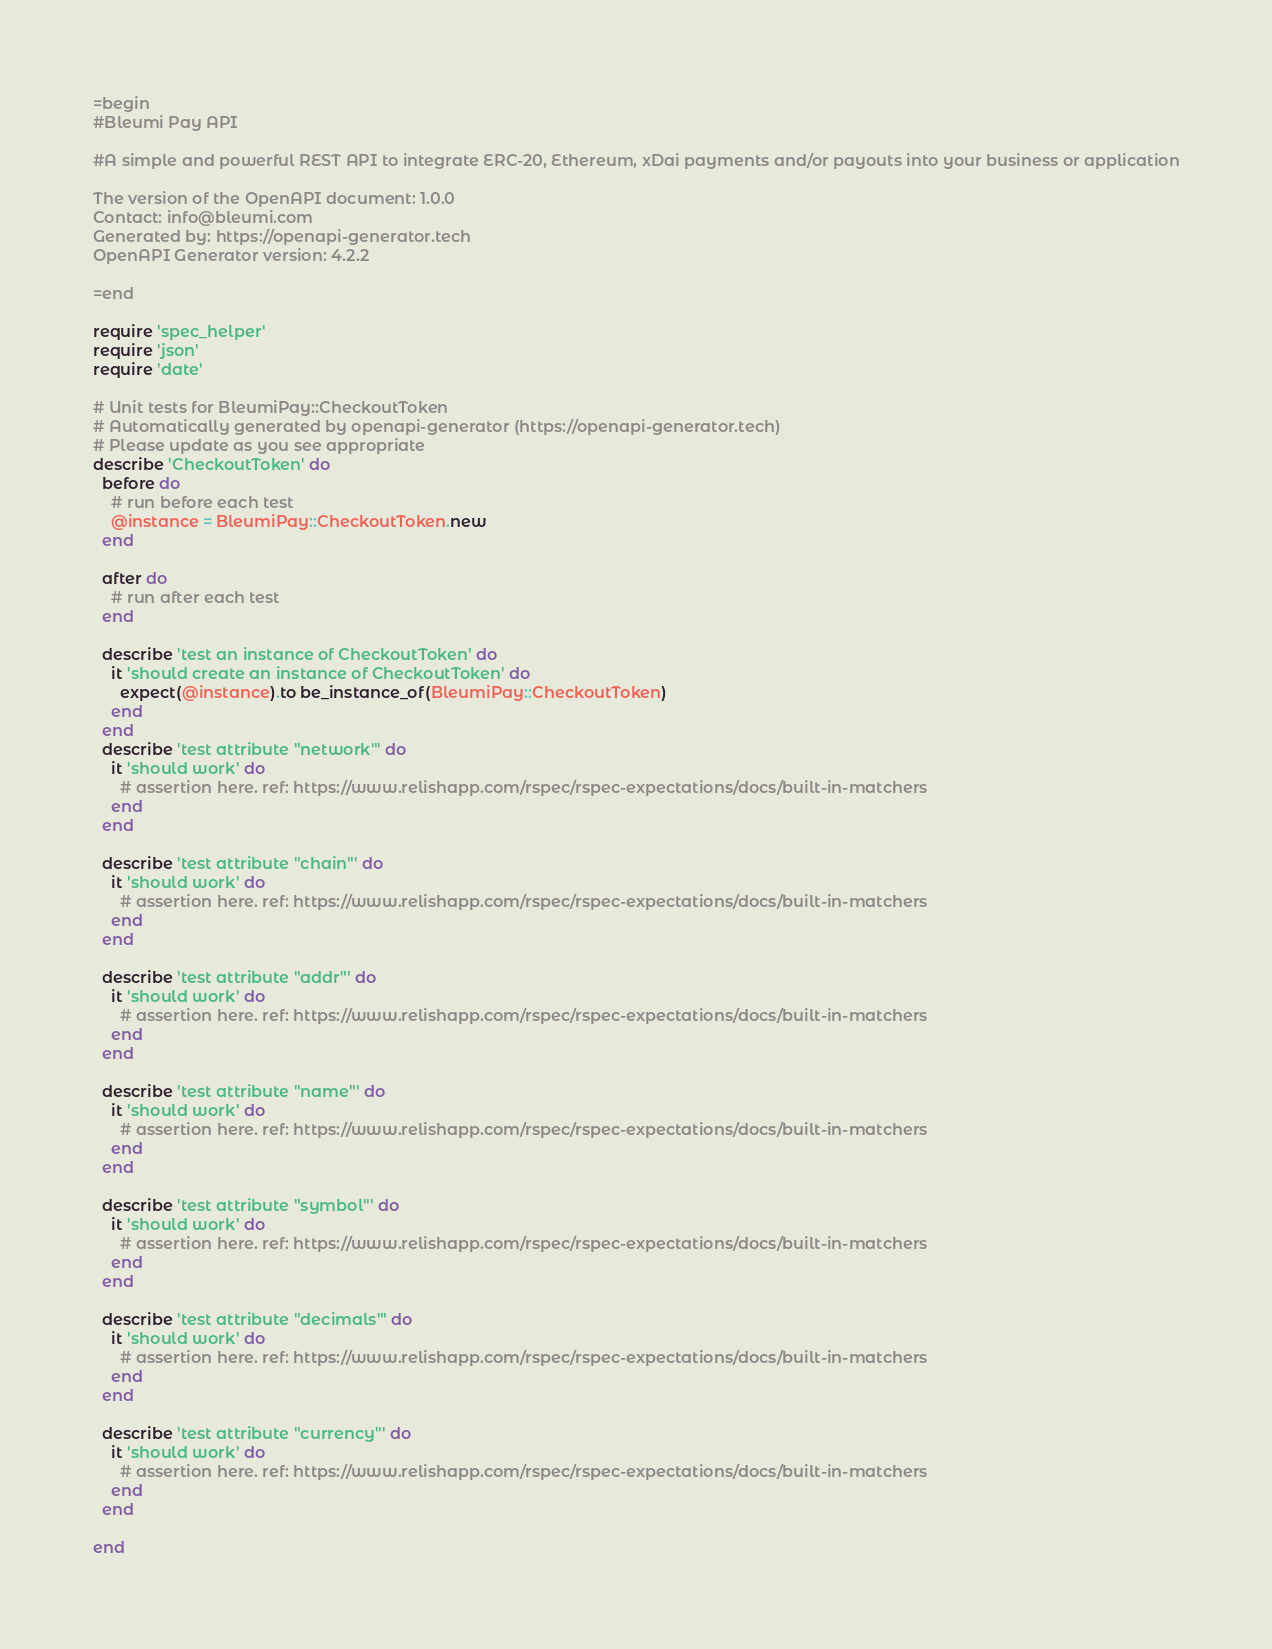Convert code to text. <code><loc_0><loc_0><loc_500><loc_500><_Ruby_>=begin
#Bleumi Pay API

#A simple and powerful REST API to integrate ERC-20, Ethereum, xDai payments and/or payouts into your business or application

The version of the OpenAPI document: 1.0.0
Contact: info@bleumi.com
Generated by: https://openapi-generator.tech
OpenAPI Generator version: 4.2.2

=end

require 'spec_helper'
require 'json'
require 'date'

# Unit tests for BleumiPay::CheckoutToken
# Automatically generated by openapi-generator (https://openapi-generator.tech)
# Please update as you see appropriate
describe 'CheckoutToken' do
  before do
    # run before each test
    @instance = BleumiPay::CheckoutToken.new
  end

  after do
    # run after each test
  end

  describe 'test an instance of CheckoutToken' do
    it 'should create an instance of CheckoutToken' do
      expect(@instance).to be_instance_of(BleumiPay::CheckoutToken)
    end
  end
  describe 'test attribute "network"' do
    it 'should work' do
      # assertion here. ref: https://www.relishapp.com/rspec/rspec-expectations/docs/built-in-matchers
    end
  end

  describe 'test attribute "chain"' do
    it 'should work' do
      # assertion here. ref: https://www.relishapp.com/rspec/rspec-expectations/docs/built-in-matchers
    end
  end

  describe 'test attribute "addr"' do
    it 'should work' do
      # assertion here. ref: https://www.relishapp.com/rspec/rspec-expectations/docs/built-in-matchers
    end
  end

  describe 'test attribute "name"' do
    it 'should work' do
      # assertion here. ref: https://www.relishapp.com/rspec/rspec-expectations/docs/built-in-matchers
    end
  end

  describe 'test attribute "symbol"' do
    it 'should work' do
      # assertion here. ref: https://www.relishapp.com/rspec/rspec-expectations/docs/built-in-matchers
    end
  end

  describe 'test attribute "decimals"' do
    it 'should work' do
      # assertion here. ref: https://www.relishapp.com/rspec/rspec-expectations/docs/built-in-matchers
    end
  end

  describe 'test attribute "currency"' do
    it 'should work' do
      # assertion here. ref: https://www.relishapp.com/rspec/rspec-expectations/docs/built-in-matchers
    end
  end

end
</code> 